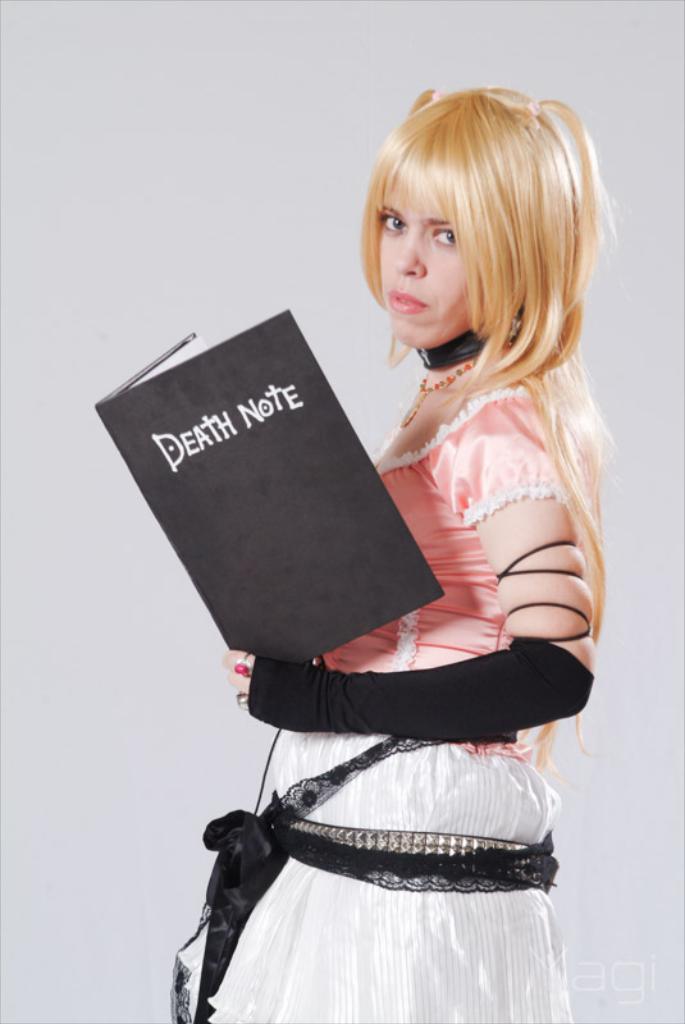Could you give a brief overview of what you see in this image? In this image there is a girl who is holding the book. 